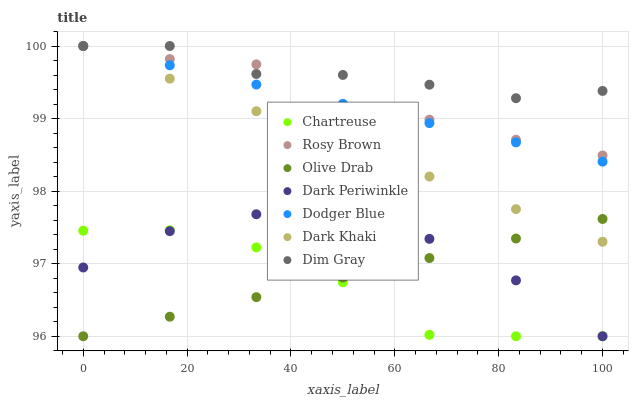Does Chartreuse have the minimum area under the curve?
Answer yes or no. Yes. Does Dim Gray have the maximum area under the curve?
Answer yes or no. Yes. Does Rosy Brown have the minimum area under the curve?
Answer yes or no. No. Does Rosy Brown have the maximum area under the curve?
Answer yes or no. No. Is Dark Khaki the smoothest?
Answer yes or no. Yes. Is Chartreuse the roughest?
Answer yes or no. Yes. Is Rosy Brown the smoothest?
Answer yes or no. No. Is Rosy Brown the roughest?
Answer yes or no. No. Does Chartreuse have the lowest value?
Answer yes or no. Yes. Does Rosy Brown have the lowest value?
Answer yes or no. No. Does Dodger Blue have the highest value?
Answer yes or no. Yes. Does Chartreuse have the highest value?
Answer yes or no. No. Is Olive Drab less than Dim Gray?
Answer yes or no. Yes. Is Dim Gray greater than Dark Periwinkle?
Answer yes or no. Yes. Does Chartreuse intersect Dark Periwinkle?
Answer yes or no. Yes. Is Chartreuse less than Dark Periwinkle?
Answer yes or no. No. Is Chartreuse greater than Dark Periwinkle?
Answer yes or no. No. Does Olive Drab intersect Dim Gray?
Answer yes or no. No. 